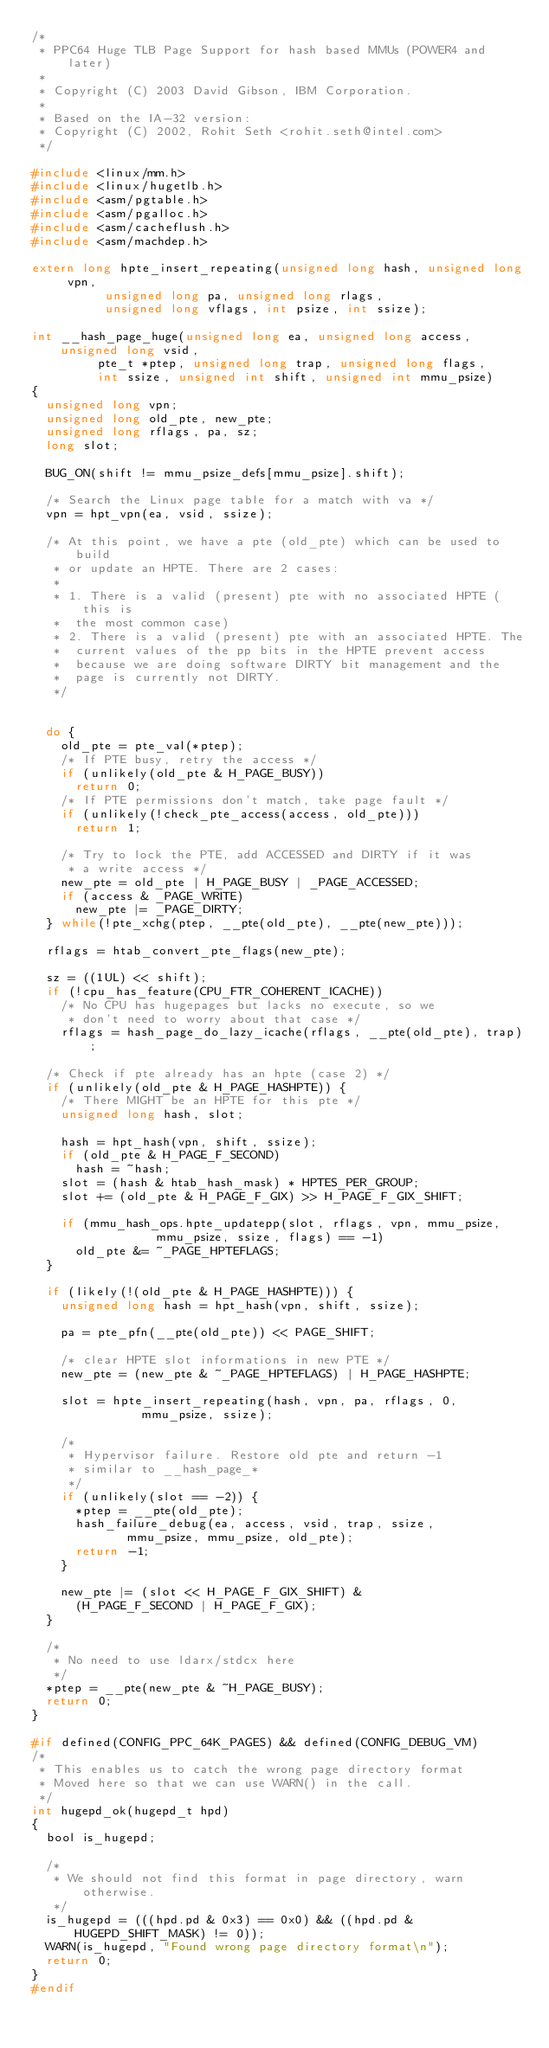<code> <loc_0><loc_0><loc_500><loc_500><_C_>/*
 * PPC64 Huge TLB Page Support for hash based MMUs (POWER4 and later)
 *
 * Copyright (C) 2003 David Gibson, IBM Corporation.
 *
 * Based on the IA-32 version:
 * Copyright (C) 2002, Rohit Seth <rohit.seth@intel.com>
 */

#include <linux/mm.h>
#include <linux/hugetlb.h>
#include <asm/pgtable.h>
#include <asm/pgalloc.h>
#include <asm/cacheflush.h>
#include <asm/machdep.h>

extern long hpte_insert_repeating(unsigned long hash, unsigned long vpn,
				  unsigned long pa, unsigned long rlags,
				  unsigned long vflags, int psize, int ssize);

int __hash_page_huge(unsigned long ea, unsigned long access, unsigned long vsid,
		     pte_t *ptep, unsigned long trap, unsigned long flags,
		     int ssize, unsigned int shift, unsigned int mmu_psize)
{
	unsigned long vpn;
	unsigned long old_pte, new_pte;
	unsigned long rflags, pa, sz;
	long slot;

	BUG_ON(shift != mmu_psize_defs[mmu_psize].shift);

	/* Search the Linux page table for a match with va */
	vpn = hpt_vpn(ea, vsid, ssize);

	/* At this point, we have a pte (old_pte) which can be used to build
	 * or update an HPTE. There are 2 cases:
	 *
	 * 1. There is a valid (present) pte with no associated HPTE (this is
	 *	the most common case)
	 * 2. There is a valid (present) pte with an associated HPTE. The
	 *	current values of the pp bits in the HPTE prevent access
	 *	because we are doing software DIRTY bit management and the
	 *	page is currently not DIRTY.
	 */


	do {
		old_pte = pte_val(*ptep);
		/* If PTE busy, retry the access */
		if (unlikely(old_pte & H_PAGE_BUSY))
			return 0;
		/* If PTE permissions don't match, take page fault */
		if (unlikely(!check_pte_access(access, old_pte)))
			return 1;

		/* Try to lock the PTE, add ACCESSED and DIRTY if it was
		 * a write access */
		new_pte = old_pte | H_PAGE_BUSY | _PAGE_ACCESSED;
		if (access & _PAGE_WRITE)
			new_pte |= _PAGE_DIRTY;
	} while(!pte_xchg(ptep, __pte(old_pte), __pte(new_pte)));

	rflags = htab_convert_pte_flags(new_pte);

	sz = ((1UL) << shift);
	if (!cpu_has_feature(CPU_FTR_COHERENT_ICACHE))
		/* No CPU has hugepages but lacks no execute, so we
		 * don't need to worry about that case */
		rflags = hash_page_do_lazy_icache(rflags, __pte(old_pte), trap);

	/* Check if pte already has an hpte (case 2) */
	if (unlikely(old_pte & H_PAGE_HASHPTE)) {
		/* There MIGHT be an HPTE for this pte */
		unsigned long hash, slot;

		hash = hpt_hash(vpn, shift, ssize);
		if (old_pte & H_PAGE_F_SECOND)
			hash = ~hash;
		slot = (hash & htab_hash_mask) * HPTES_PER_GROUP;
		slot += (old_pte & H_PAGE_F_GIX) >> H_PAGE_F_GIX_SHIFT;

		if (mmu_hash_ops.hpte_updatepp(slot, rflags, vpn, mmu_psize,
					       mmu_psize, ssize, flags) == -1)
			old_pte &= ~_PAGE_HPTEFLAGS;
	}

	if (likely(!(old_pte & H_PAGE_HASHPTE))) {
		unsigned long hash = hpt_hash(vpn, shift, ssize);

		pa = pte_pfn(__pte(old_pte)) << PAGE_SHIFT;

		/* clear HPTE slot informations in new PTE */
		new_pte = (new_pte & ~_PAGE_HPTEFLAGS) | H_PAGE_HASHPTE;

		slot = hpte_insert_repeating(hash, vpn, pa, rflags, 0,
					     mmu_psize, ssize);

		/*
		 * Hypervisor failure. Restore old pte and return -1
		 * similar to __hash_page_*
		 */
		if (unlikely(slot == -2)) {
			*ptep = __pte(old_pte);
			hash_failure_debug(ea, access, vsid, trap, ssize,
					   mmu_psize, mmu_psize, old_pte);
			return -1;
		}

		new_pte |= (slot << H_PAGE_F_GIX_SHIFT) &
			(H_PAGE_F_SECOND | H_PAGE_F_GIX);
	}

	/*
	 * No need to use ldarx/stdcx here
	 */
	*ptep = __pte(new_pte & ~H_PAGE_BUSY);
	return 0;
}

#if defined(CONFIG_PPC_64K_PAGES) && defined(CONFIG_DEBUG_VM)
/*
 * This enables us to catch the wrong page directory format
 * Moved here so that we can use WARN() in the call.
 */
int hugepd_ok(hugepd_t hpd)
{
	bool is_hugepd;

	/*
	 * We should not find this format in page directory, warn otherwise.
	 */
	is_hugepd = (((hpd.pd & 0x3) == 0x0) && ((hpd.pd & HUGEPD_SHIFT_MASK) != 0));
	WARN(is_hugepd, "Found wrong page directory format\n");
	return 0;
}
#endif
</code> 